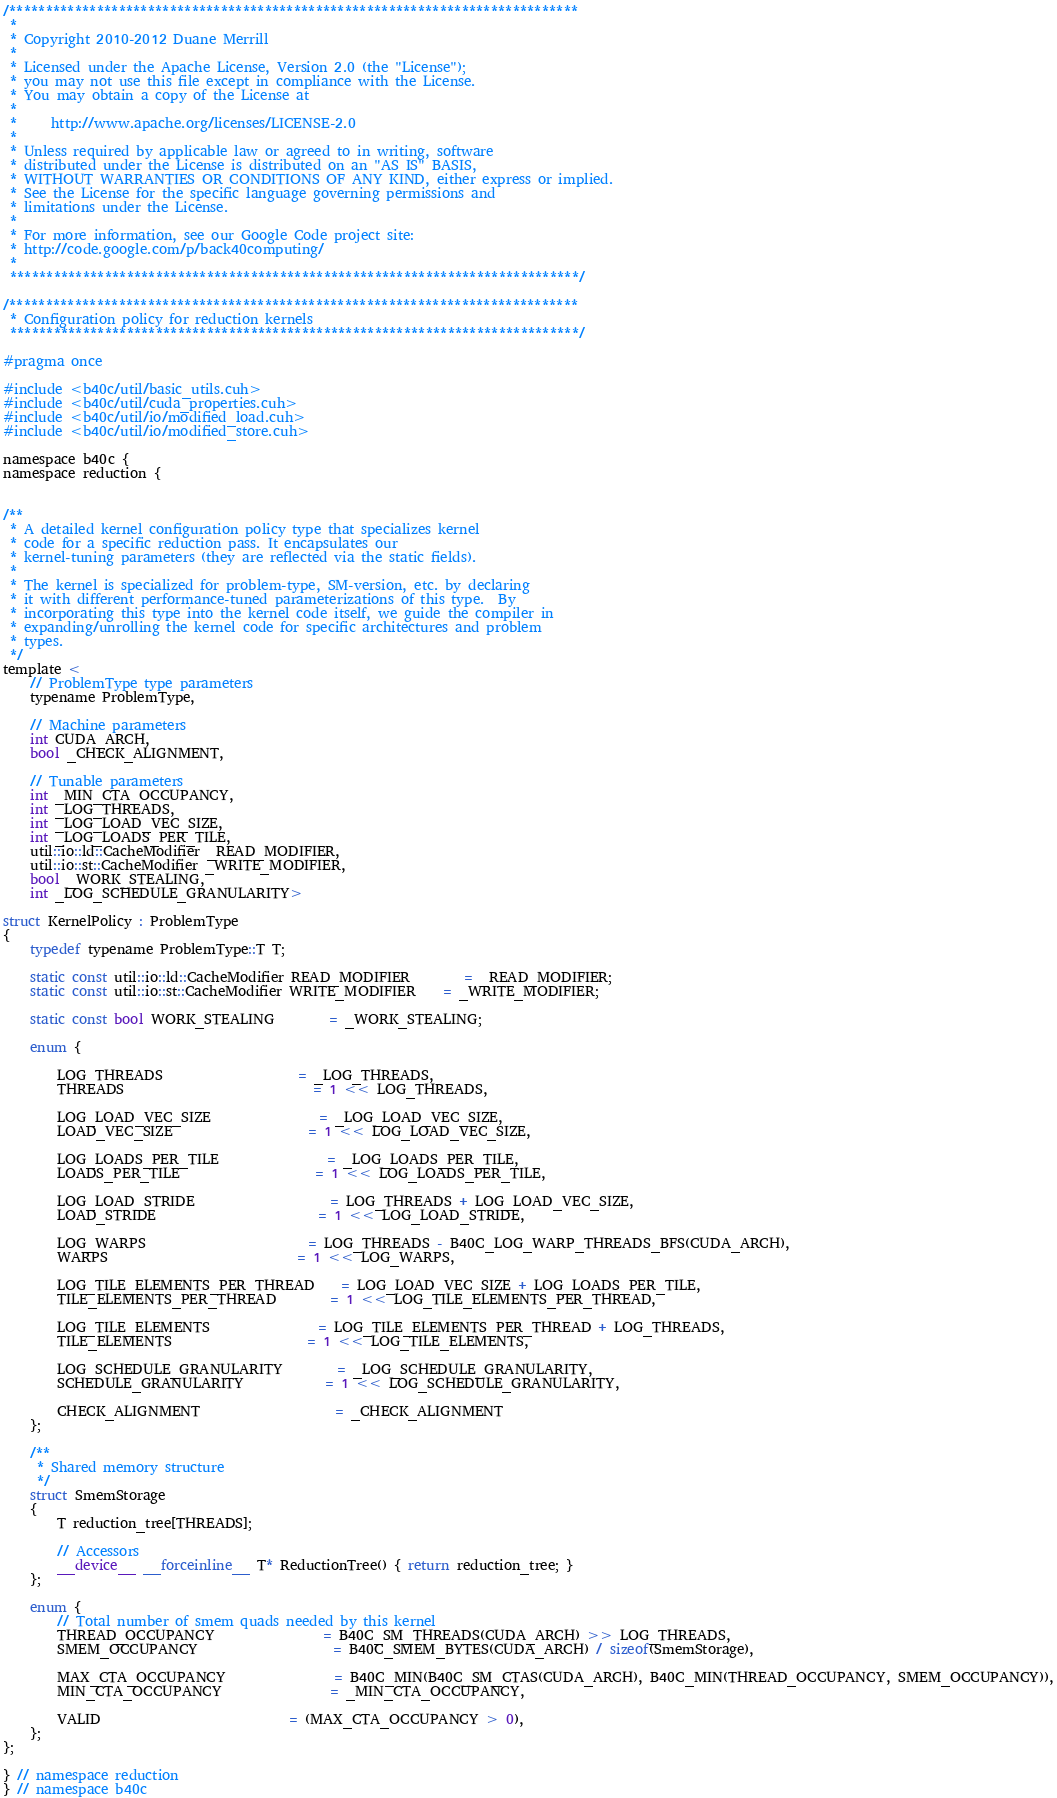Convert code to text. <code><loc_0><loc_0><loc_500><loc_500><_Cuda_>/******************************************************************************
 * 
 * Copyright 2010-2012 Duane Merrill
 * 
 * Licensed under the Apache License, Version 2.0 (the "License");
 * you may not use this file except in compliance with the License.
 * You may obtain a copy of the License at
 * 
 *     http://www.apache.org/licenses/LICENSE-2.0
 *
 * Unless required by applicable law or agreed to in writing, software
 * distributed under the License is distributed on an "AS IS" BASIS,
 * WITHOUT WARRANTIES OR CONDITIONS OF ANY KIND, either express or implied.
 * See the License for the specific language governing permissions and
 * limitations under the License. 
 * 
 * For more information, see our Google Code project site: 
 * http://code.google.com/p/back40computing/
 * 
 ******************************************************************************/

/******************************************************************************
 * Configuration policy for reduction kernels
 ******************************************************************************/

#pragma once

#include <b40c/util/basic_utils.cuh>
#include <b40c/util/cuda_properties.cuh>
#include <b40c/util/io/modified_load.cuh>
#include <b40c/util/io/modified_store.cuh>

namespace b40c {
namespace reduction {


/**
 * A detailed kernel configuration policy type that specializes kernel
 * code for a specific reduction pass. It encapsulates our
 * kernel-tuning parameters (they are reflected via the static fields).
 *
 * The kernel is specialized for problem-type, SM-version, etc. by declaring
 * it with different performance-tuned parameterizations of this type.  By
 * incorporating this type into the kernel code itself, we guide the compiler in
 * expanding/unrolling the kernel code for specific architectures and problem
 * types.
 */
template <
	// ProblemType type parameters
	typename ProblemType,

	// Machine parameters
	int CUDA_ARCH,
	bool _CHECK_ALIGNMENT,

	// Tunable parameters
	int _MIN_CTA_OCCUPANCY,
	int _LOG_THREADS,
	int _LOG_LOAD_VEC_SIZE,
	int _LOG_LOADS_PER_TILE,
	util::io::ld::CacheModifier _READ_MODIFIER,
	util::io::st::CacheModifier _WRITE_MODIFIER,
	bool _WORK_STEALING,
	int _LOG_SCHEDULE_GRANULARITY>

struct KernelPolicy : ProblemType
{
	typedef typename ProblemType::T T;

	static const util::io::ld::CacheModifier READ_MODIFIER 		= _READ_MODIFIER;
	static const util::io::st::CacheModifier WRITE_MODIFIER 	= _WRITE_MODIFIER;

	static const bool WORK_STEALING		= _WORK_STEALING;

	enum {

		LOG_THREADS 					= _LOG_THREADS,
		THREADS							= 1 << LOG_THREADS,

		LOG_LOAD_VEC_SIZE  				= _LOG_LOAD_VEC_SIZE,
		LOAD_VEC_SIZE					= 1 << LOG_LOAD_VEC_SIZE,

		LOG_LOADS_PER_TILE 				= _LOG_LOADS_PER_TILE,
		LOADS_PER_TILE					= 1 << LOG_LOADS_PER_TILE,

		LOG_LOAD_STRIDE					= LOG_THREADS + LOG_LOAD_VEC_SIZE,
		LOAD_STRIDE						= 1 << LOG_LOAD_STRIDE,

		LOG_WARPS						= LOG_THREADS - B40C_LOG_WARP_THREADS_BFS(CUDA_ARCH),
		WARPS							= 1 << LOG_WARPS,

		LOG_TILE_ELEMENTS_PER_THREAD	= LOG_LOAD_VEC_SIZE + LOG_LOADS_PER_TILE,
		TILE_ELEMENTS_PER_THREAD		= 1 << LOG_TILE_ELEMENTS_PER_THREAD,

		LOG_TILE_ELEMENTS 				= LOG_TILE_ELEMENTS_PER_THREAD + LOG_THREADS,
		TILE_ELEMENTS					= 1 << LOG_TILE_ELEMENTS,

		LOG_SCHEDULE_GRANULARITY		= _LOG_SCHEDULE_GRANULARITY,
		SCHEDULE_GRANULARITY			= 1 << LOG_SCHEDULE_GRANULARITY,

		CHECK_ALIGNMENT					= _CHECK_ALIGNMENT
	};

	/**
	 * Shared memory structure
	 */
	struct SmemStorage
	{
		T reduction_tree[THREADS];

		// Accessors
		__device__ __forceinline__ T* ReductionTree() { return reduction_tree; }
	};

	enum {
		// Total number of smem quads needed by this kernel
		THREAD_OCCUPANCY				= B40C_SM_THREADS(CUDA_ARCH) >> LOG_THREADS,
		SMEM_OCCUPANCY					= B40C_SMEM_BYTES(CUDA_ARCH) / sizeof(SmemStorage),

		MAX_CTA_OCCUPANCY  				= B40C_MIN(B40C_SM_CTAS(CUDA_ARCH), B40C_MIN(THREAD_OCCUPANCY, SMEM_OCCUPANCY)),
		MIN_CTA_OCCUPANCY				= _MIN_CTA_OCCUPANCY,

		VALID							= (MAX_CTA_OCCUPANCY > 0),
	};
};

} // namespace reduction
} // namespace b40c

</code> 